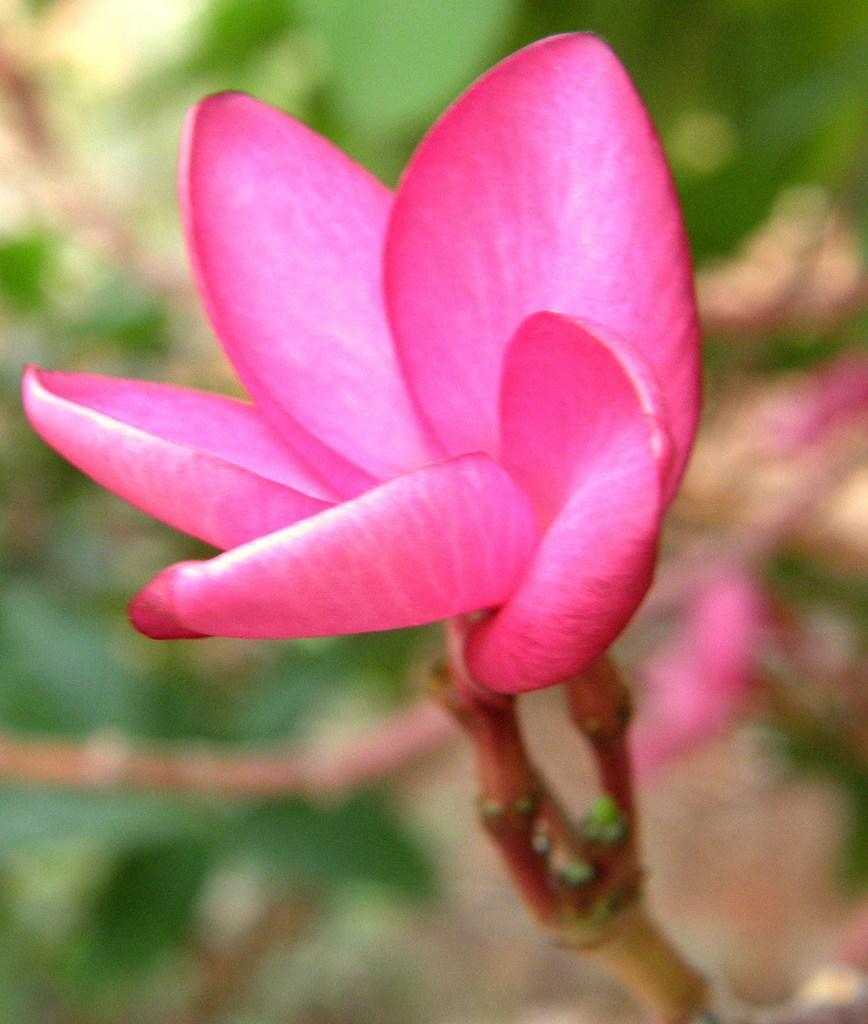What type of flower is in the image? There is a pink color flower in the image. Can you describe the flower's structure? The flower has a stem. What type of verse is written on the flower in the image? There is no verse written on the flower in the image; it is a simple pink flower with a stem. 